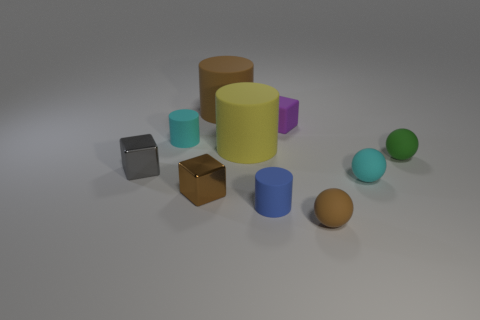What number of other things are the same material as the green ball?
Ensure brevity in your answer.  7. How many matte objects are either cyan things or small green spheres?
Provide a succinct answer. 3. The other large rubber thing that is the same shape as the yellow matte thing is what color?
Your answer should be compact. Brown. What number of things are small brown matte things or cyan metal objects?
Your response must be concise. 1. What is the shape of the blue object that is the same material as the tiny brown ball?
Offer a terse response. Cylinder. What number of big objects are either metallic blocks or gray blocks?
Your answer should be compact. 0. What number of other objects are the same color as the matte block?
Ensure brevity in your answer.  0. There is a large brown cylinder that is behind the small purple matte block that is behind the gray shiny cube; how many large brown matte things are right of it?
Give a very brief answer. 0. Does the metal object that is in front of the cyan sphere have the same size as the tiny purple object?
Keep it short and to the point. Yes. Is the number of brown metal things on the right side of the small green sphere less than the number of cyan balls right of the blue rubber cylinder?
Your response must be concise. Yes. 